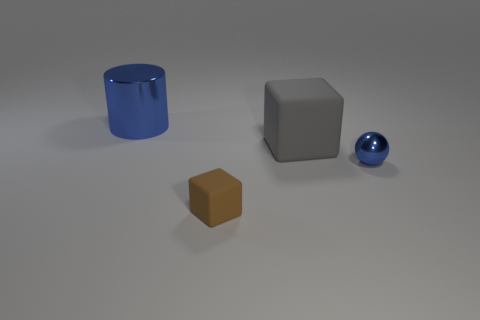What material is the big object that is right of the tiny object in front of the blue object that is right of the small brown cube made of?
Offer a terse response. Rubber. There is a rubber thing that is behind the tiny blue metal object; is it the same shape as the blue object to the right of the blue cylinder?
Ensure brevity in your answer.  No. The large object that is in front of the blue object that is behind the gray block is what color?
Ensure brevity in your answer.  Gray. How many cylinders are either big gray things or small brown matte objects?
Your answer should be compact. 0. There is a metal object that is behind the blue thing that is to the right of the big block; what number of tiny shiny spheres are behind it?
Offer a terse response. 0. There is a thing that is the same color as the metallic sphere; what is its size?
Your response must be concise. Large. Is there a gray sphere that has the same material as the big cube?
Make the answer very short. No. Does the tiny sphere have the same material as the brown object?
Offer a very short reply. No. What number of tiny metallic objects are in front of the metallic object to the left of the metal ball?
Your answer should be very brief. 1. What number of gray objects are big matte blocks or tiny metal objects?
Make the answer very short. 1. 